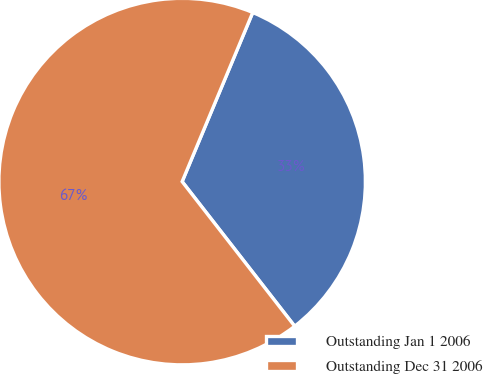Convert chart to OTSL. <chart><loc_0><loc_0><loc_500><loc_500><pie_chart><fcel>Outstanding Jan 1 2006<fcel>Outstanding Dec 31 2006<nl><fcel>33.18%<fcel>66.82%<nl></chart> 